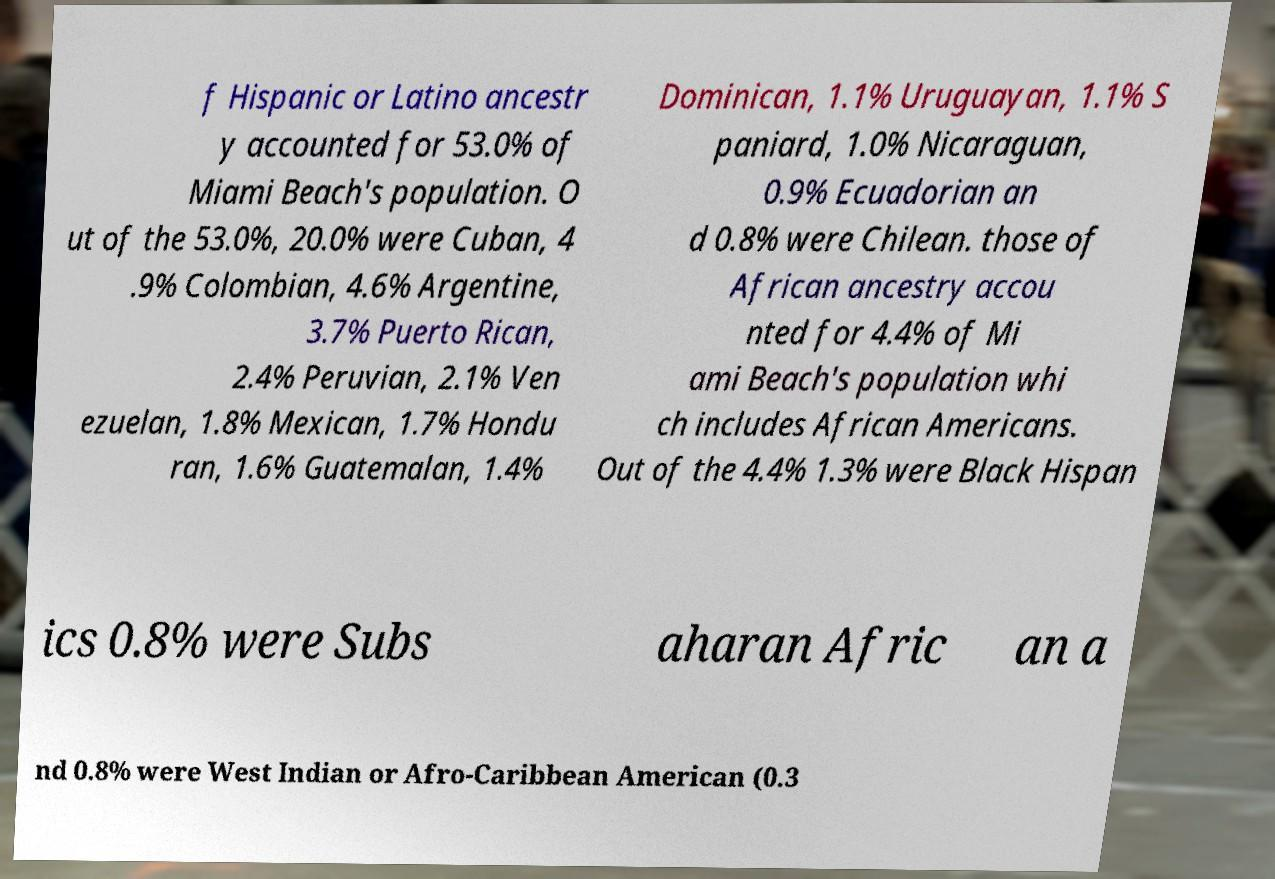For documentation purposes, I need the text within this image transcribed. Could you provide that? f Hispanic or Latino ancestr y accounted for 53.0% of Miami Beach's population. O ut of the 53.0%, 20.0% were Cuban, 4 .9% Colombian, 4.6% Argentine, 3.7% Puerto Rican, 2.4% Peruvian, 2.1% Ven ezuelan, 1.8% Mexican, 1.7% Hondu ran, 1.6% Guatemalan, 1.4% Dominican, 1.1% Uruguayan, 1.1% S paniard, 1.0% Nicaraguan, 0.9% Ecuadorian an d 0.8% were Chilean. those of African ancestry accou nted for 4.4% of Mi ami Beach's population whi ch includes African Americans. Out of the 4.4% 1.3% were Black Hispan ics 0.8% were Subs aharan Afric an a nd 0.8% were West Indian or Afro-Caribbean American (0.3 